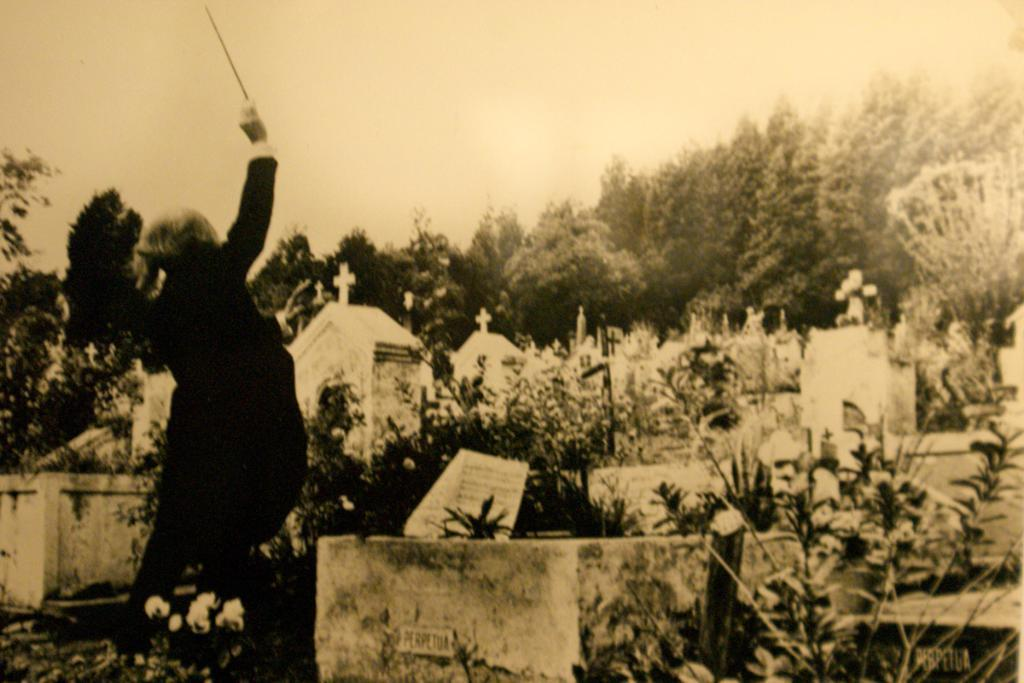What type of structures can be seen in the image? There are graves in the image. What other elements are present in the image besides the graves? There are plants and trees in the image. Can you describe the person in the image? There is a person on the left side of the image, and they are holding a stick. What shape do the fairies in the image take? There are no fairies present in the image. What process is being carried out by the person holding the stick in the image? The image does not provide enough information to determine what process the person might be engaged in. 